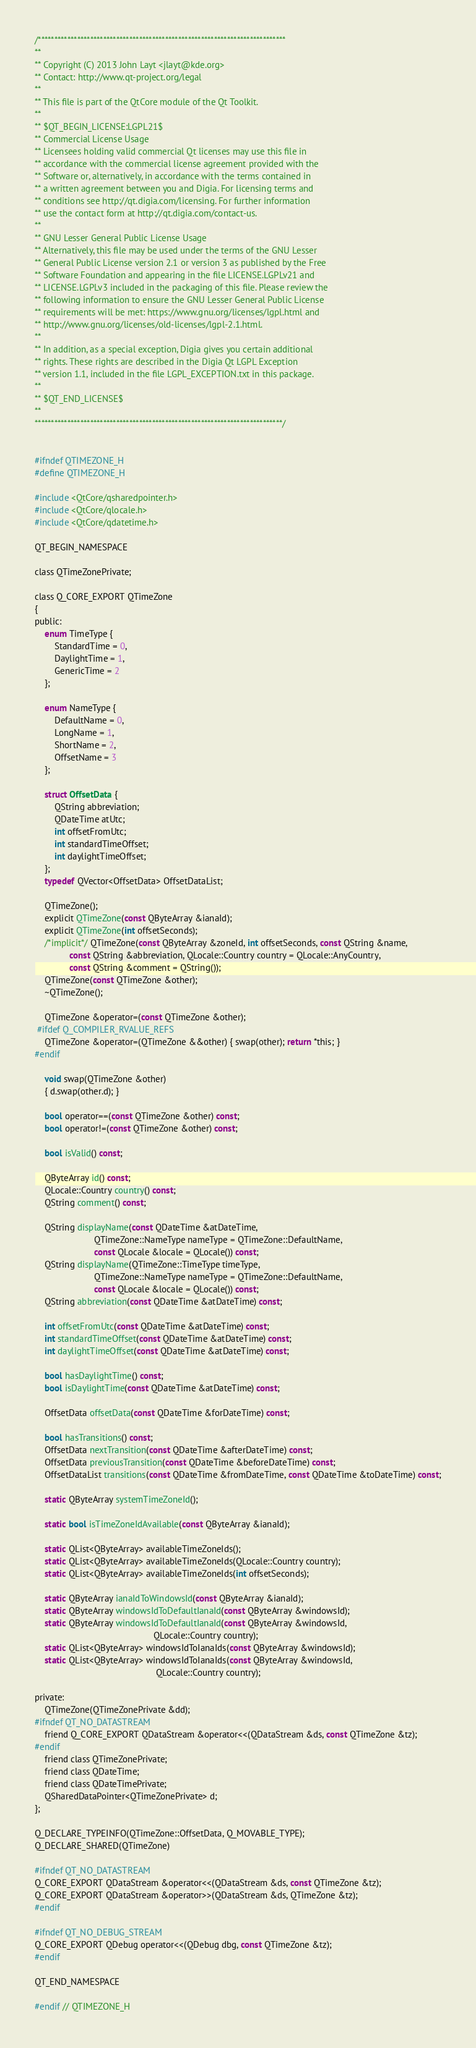Convert code to text. <code><loc_0><loc_0><loc_500><loc_500><_C_>/****************************************************************************
**
** Copyright (C) 2013 John Layt <jlayt@kde.org>
** Contact: http://www.qt-project.org/legal
**
** This file is part of the QtCore module of the Qt Toolkit.
**
** $QT_BEGIN_LICENSE:LGPL21$
** Commercial License Usage
** Licensees holding valid commercial Qt licenses may use this file in
** accordance with the commercial license agreement provided with the
** Software or, alternatively, in accordance with the terms contained in
** a written agreement between you and Digia. For licensing terms and
** conditions see http://qt.digia.com/licensing. For further information
** use the contact form at http://qt.digia.com/contact-us.
**
** GNU Lesser General Public License Usage
** Alternatively, this file may be used under the terms of the GNU Lesser
** General Public License version 2.1 or version 3 as published by the Free
** Software Foundation and appearing in the file LICENSE.LGPLv21 and
** LICENSE.LGPLv3 included in the packaging of this file. Please review the
** following information to ensure the GNU Lesser General Public License
** requirements will be met: https://www.gnu.org/licenses/lgpl.html and
** http://www.gnu.org/licenses/old-licenses/lgpl-2.1.html.
**
** In addition, as a special exception, Digia gives you certain additional
** rights. These rights are described in the Digia Qt LGPL Exception
** version 1.1, included in the file LGPL_EXCEPTION.txt in this package.
**
** $QT_END_LICENSE$
**
****************************************************************************/


#ifndef QTIMEZONE_H
#define QTIMEZONE_H

#include <QtCore/qsharedpointer.h>
#include <QtCore/qlocale.h>
#include <QtCore/qdatetime.h>

QT_BEGIN_NAMESPACE

class QTimeZonePrivate;

class Q_CORE_EXPORT QTimeZone
{
public:
    enum TimeType {
        StandardTime = 0,
        DaylightTime = 1,
        GenericTime = 2
    };

    enum NameType {
        DefaultName = 0,
        LongName = 1,
        ShortName = 2,
        OffsetName = 3
    };

    struct OffsetData {
        QString abbreviation;
        QDateTime atUtc;
        int offsetFromUtc;
        int standardTimeOffset;
        int daylightTimeOffset;
    };
    typedef QVector<OffsetData> OffsetDataList;

    QTimeZone();
    explicit QTimeZone(const QByteArray &ianaId);
    explicit QTimeZone(int offsetSeconds);
    /*implicit*/ QTimeZone(const QByteArray &zoneId, int offsetSeconds, const QString &name,
              const QString &abbreviation, QLocale::Country country = QLocale::AnyCountry,
              const QString &comment = QString());
    QTimeZone(const QTimeZone &other);
    ~QTimeZone();

    QTimeZone &operator=(const QTimeZone &other);
 #ifdef Q_COMPILER_RVALUE_REFS
    QTimeZone &operator=(QTimeZone &&other) { swap(other); return *this; }
#endif

    void swap(QTimeZone &other)
    { d.swap(other.d); }

    bool operator==(const QTimeZone &other) const;
    bool operator!=(const QTimeZone &other) const;

    bool isValid() const;

    QByteArray id() const;
    QLocale::Country country() const;
    QString comment() const;

    QString displayName(const QDateTime &atDateTime,
                        QTimeZone::NameType nameType = QTimeZone::DefaultName,
                        const QLocale &locale = QLocale()) const;
    QString displayName(QTimeZone::TimeType timeType,
                        QTimeZone::NameType nameType = QTimeZone::DefaultName,
                        const QLocale &locale = QLocale()) const;
    QString abbreviation(const QDateTime &atDateTime) const;

    int offsetFromUtc(const QDateTime &atDateTime) const;
    int standardTimeOffset(const QDateTime &atDateTime) const;
    int daylightTimeOffset(const QDateTime &atDateTime) const;

    bool hasDaylightTime() const;
    bool isDaylightTime(const QDateTime &atDateTime) const;

    OffsetData offsetData(const QDateTime &forDateTime) const;

    bool hasTransitions() const;
    OffsetData nextTransition(const QDateTime &afterDateTime) const;
    OffsetData previousTransition(const QDateTime &beforeDateTime) const;
    OffsetDataList transitions(const QDateTime &fromDateTime, const QDateTime &toDateTime) const;

    static QByteArray systemTimeZoneId();

    static bool isTimeZoneIdAvailable(const QByteArray &ianaId);

    static QList<QByteArray> availableTimeZoneIds();
    static QList<QByteArray> availableTimeZoneIds(QLocale::Country country);
    static QList<QByteArray> availableTimeZoneIds(int offsetSeconds);

    static QByteArray ianaIdToWindowsId(const QByteArray &ianaId);
    static QByteArray windowsIdToDefaultIanaId(const QByteArray &windowsId);
    static QByteArray windowsIdToDefaultIanaId(const QByteArray &windowsId,
                                                QLocale::Country country);
    static QList<QByteArray> windowsIdToIanaIds(const QByteArray &windowsId);
    static QList<QByteArray> windowsIdToIanaIds(const QByteArray &windowsId,
                                                 QLocale::Country country);

private:
    QTimeZone(QTimeZonePrivate &dd);
#ifndef QT_NO_DATASTREAM
    friend Q_CORE_EXPORT QDataStream &operator<<(QDataStream &ds, const QTimeZone &tz);
#endif
    friend class QTimeZonePrivate;
    friend class QDateTime;
    friend class QDateTimePrivate;
    QSharedDataPointer<QTimeZonePrivate> d;
};

Q_DECLARE_TYPEINFO(QTimeZone::OffsetData, Q_MOVABLE_TYPE);
Q_DECLARE_SHARED(QTimeZone)

#ifndef QT_NO_DATASTREAM
Q_CORE_EXPORT QDataStream &operator<<(QDataStream &ds, const QTimeZone &tz);
Q_CORE_EXPORT QDataStream &operator>>(QDataStream &ds, QTimeZone &tz);
#endif

#ifndef QT_NO_DEBUG_STREAM
Q_CORE_EXPORT QDebug operator<<(QDebug dbg, const QTimeZone &tz);
#endif

QT_END_NAMESPACE

#endif // QTIMEZONE_H
</code> 